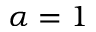<formula> <loc_0><loc_0><loc_500><loc_500>\alpha = 1</formula> 